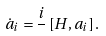<formula> <loc_0><loc_0><loc_500><loc_500>\dot { a } _ { i } = \frac { i } { } \left [ H , a _ { i } \right ] .</formula> 